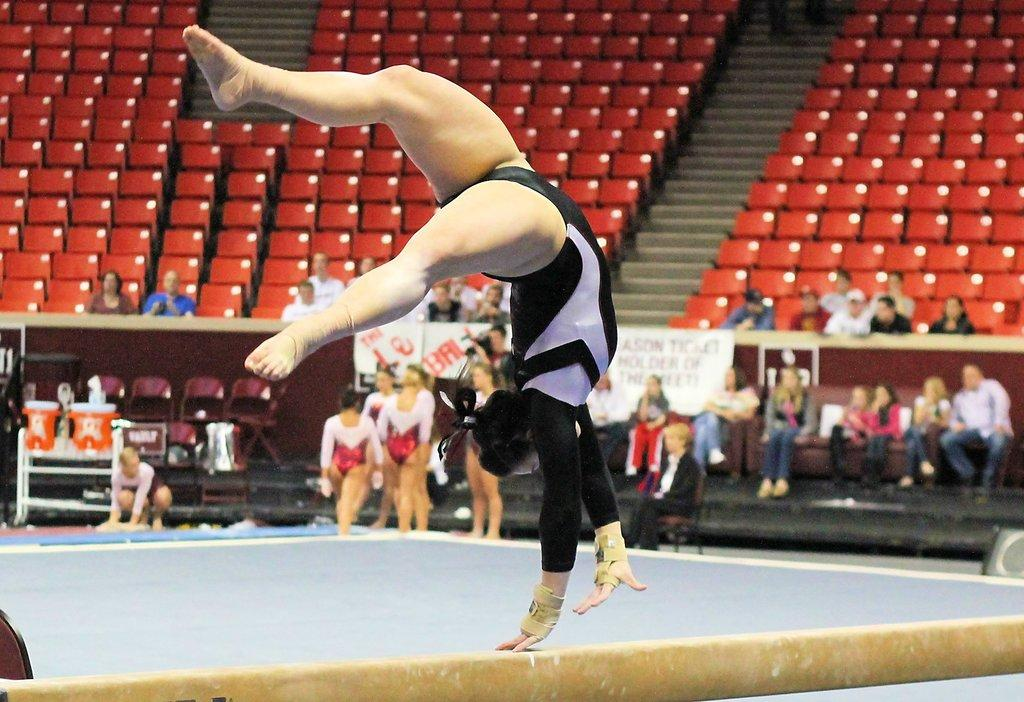What is the woman in the image doing? The woman is performing gymnastics in the image. What can be seen in the background of the image? There are persons, chairs, and stairs in the background of the image. What type of coat is the woman wearing while performing gymnastics in the image? The woman is not wearing a coat in the image; she is dressed in gymnastics attire. What material is the wool used for the gymnastics mat in the image? There is no mention of a gymnastics mat or wool in the image. 